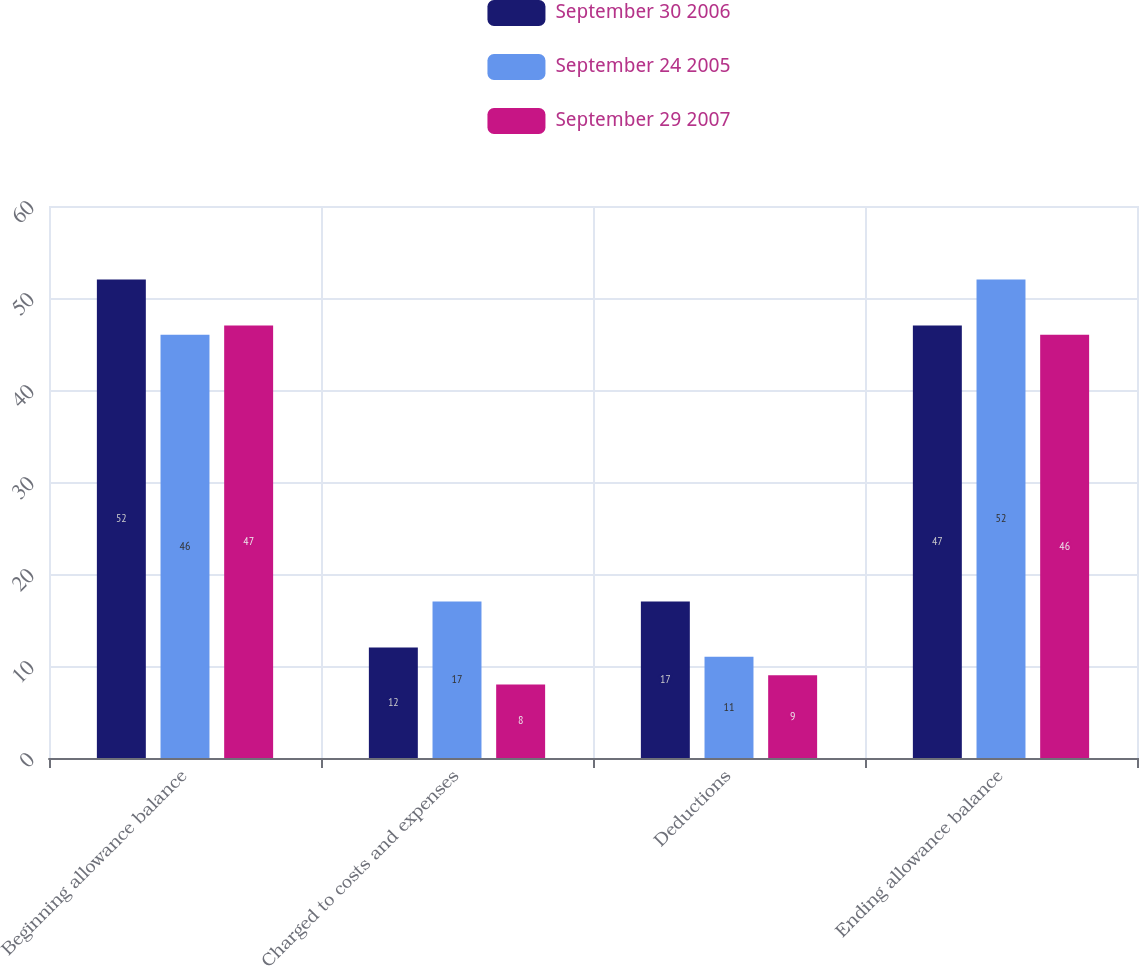<chart> <loc_0><loc_0><loc_500><loc_500><stacked_bar_chart><ecel><fcel>Beginning allowance balance<fcel>Charged to costs and expenses<fcel>Deductions<fcel>Ending allowance balance<nl><fcel>September 30 2006<fcel>52<fcel>12<fcel>17<fcel>47<nl><fcel>September 24 2005<fcel>46<fcel>17<fcel>11<fcel>52<nl><fcel>September 29 2007<fcel>47<fcel>8<fcel>9<fcel>46<nl></chart> 